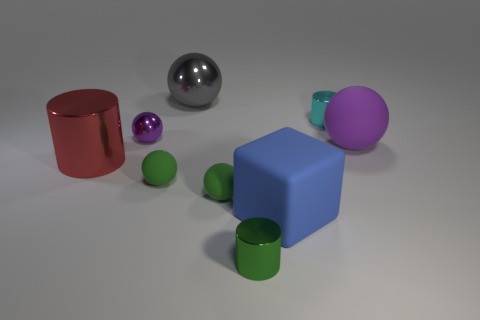Is there a blue cube made of the same material as the big red cylinder? no 